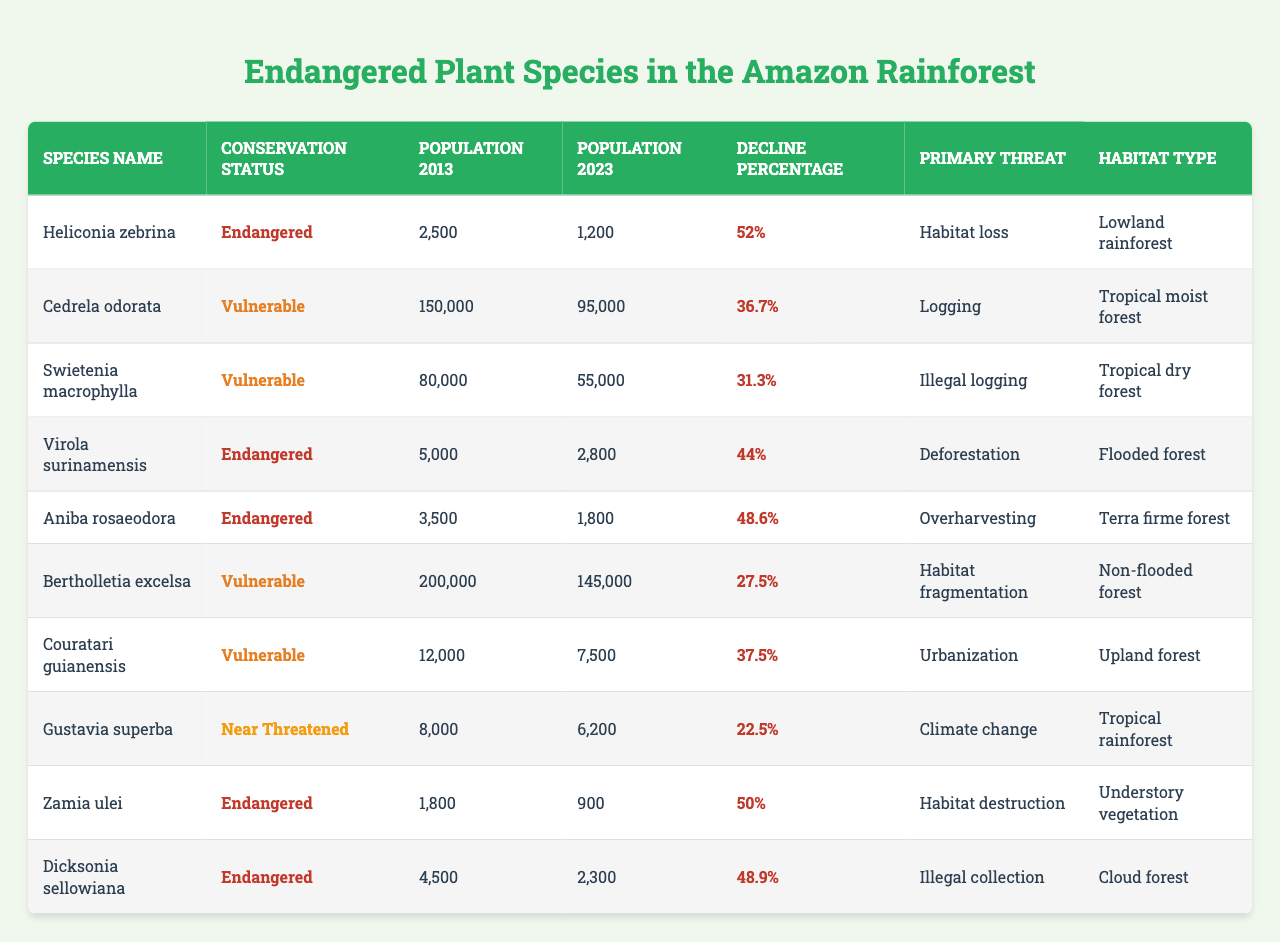What is the population of Heliconia zebrina in 2023? The table shows that the population of Heliconia zebrina in 2023 is listed in the corresponding column as 1200.
Answer: 1200 Which plant species has the highest population decline percentage? By examining the decline percentage column, Heliconia zebrina has the highest decline at 52%.
Answer: 52% What is the conservation status of Aniba rosaeodora? The table indicates that Aniba rosaeodora is categorized under the conservation status as "Endangered".
Answer: Endangered How many species have a population of less than 2000 in 2023? From the table, we identify species with populations of 1800 (Aniba rosaeodora) and 900 (Zamia ulei), totaling 2 species.
Answer: 2 What is the primary threat for Virola surinamensis? The table directly states that the primary threat for Virola surinamensis is "Deforestation".
Answer: Deforestation Calculate the average population decline percentage for all the endangered species listed. The decline percentages for the endangered species are 52, 44, 48.6, 50, and 48.9. The sum is 243.5 and there are 5 species, so 243.5/5 = 48.7.
Answer: 48.7 Is Cedrela odorata's population in 2023 more than that of Swietenia macrophylla? The population of Cedrela odorata in 2023 is 95000, whereas Swietenia macrophylla's is 55000; therefore, Cedrela odorata's population is greater.
Answer: Yes Which habitat type is associated with the species exhibiting the least population in 2023? The species with the least population is Zamia ulei, which belongs to the "Understory vegetation" habitat type.
Answer: Understory vegetation What is the difference in population between Bertholletia excelsa in 2013 and 2023? The population of Bertholletia excelsa in 2013 is 200000, and in 2023 it is 145000. The difference is 200000 - 145000 = 55000.
Answer: 55000 Are there more "Vulnerable" or "Endangered" species listed in the table? The table lists 3 "Endangered" species (Heliconia zebrina, Virola surinamensis, Aniba rosaeodora, Dicksonia sellowiana) and 4 "Vulnerable" species (Cedrela odorata, Swietenia macrophylla, Bertholletia excelsa, Couratari guianensis); there are more "Vulnerable" species.
Answer: Vulnerable 